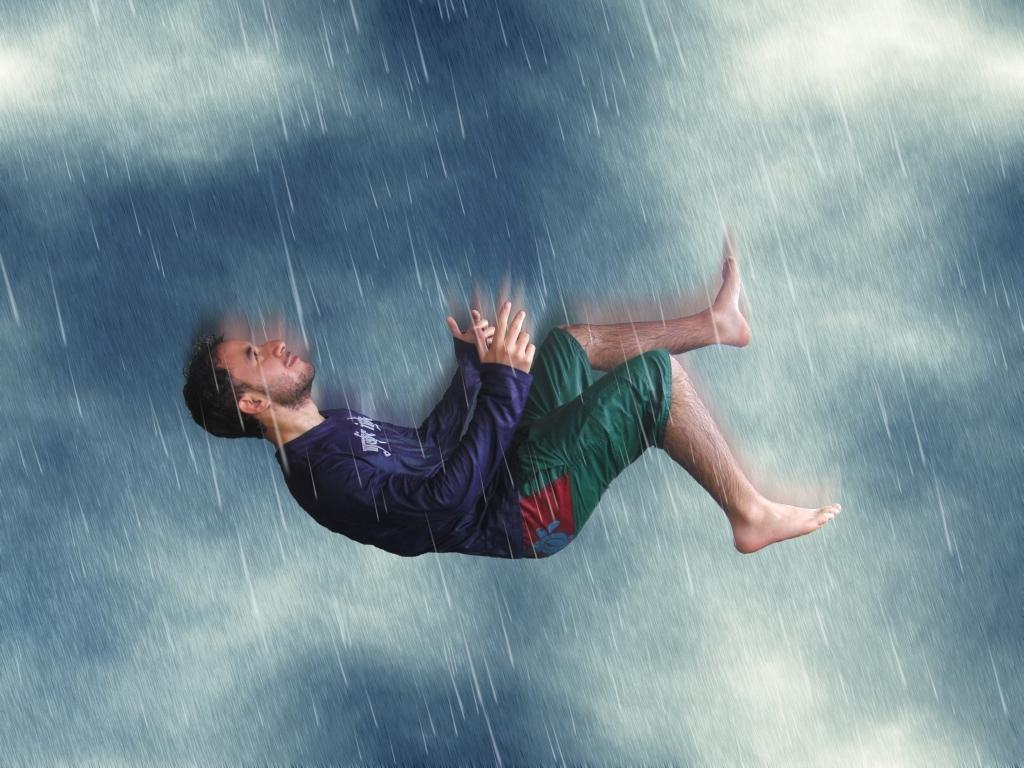What is the main subject of the image? The main subject of the image is a man. What type of clothing is the man wearing? The man is wearing a t-shirt and shorts. Can you describe any special effects or conditions in the image? The image appears to be edited to simulate rain. What is the weight of the quince in the image? There is no quince present in the image, so it's not possible to determine its weight. 